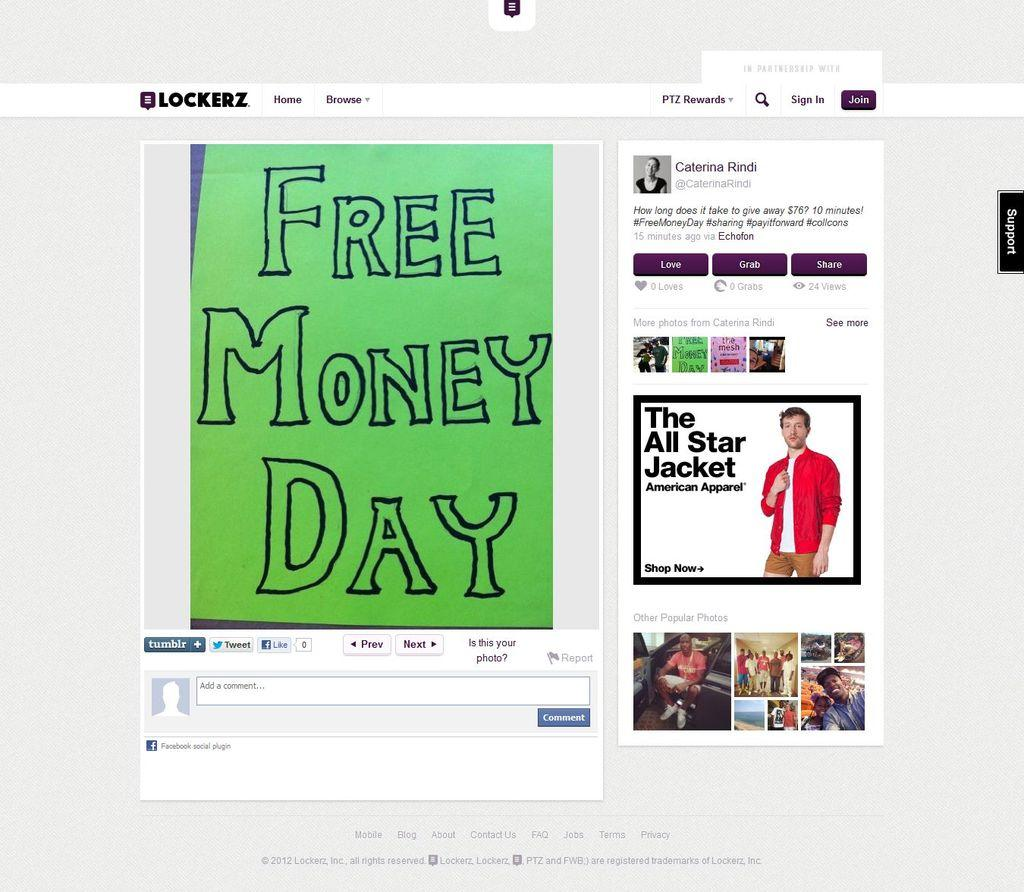<image>
Describe the image concisely. A green sign that reads Free Money Day on the website Blockerz. 